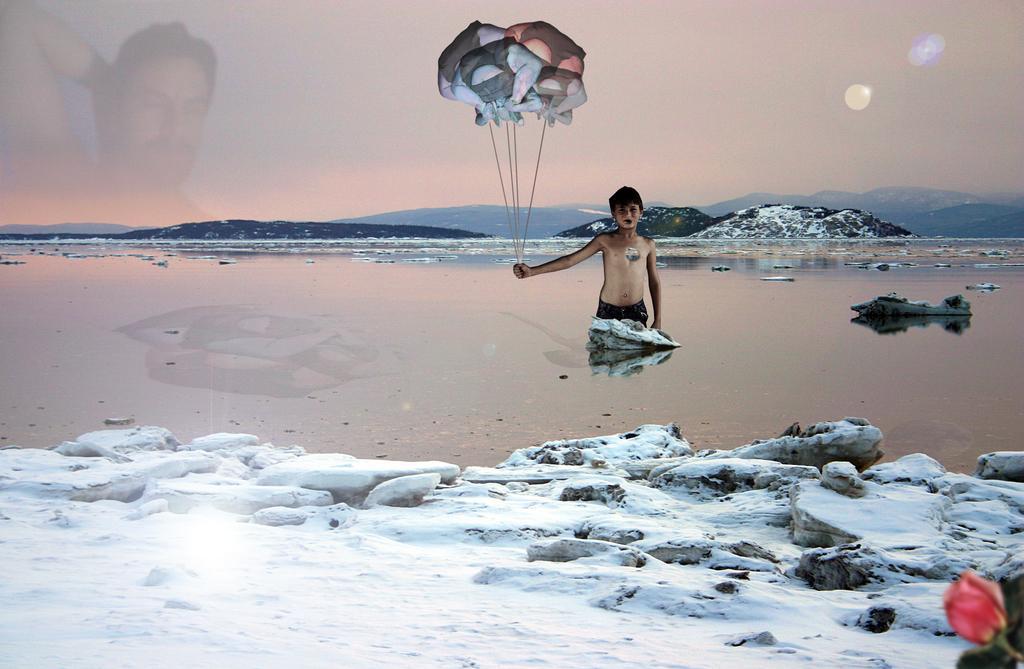Can you describe this image briefly? In this picture we can observe a river. There is a boy holding some balloons in his hand. We can observe snow. In the background there are hills and a sky on the left side. We can observe a man. 